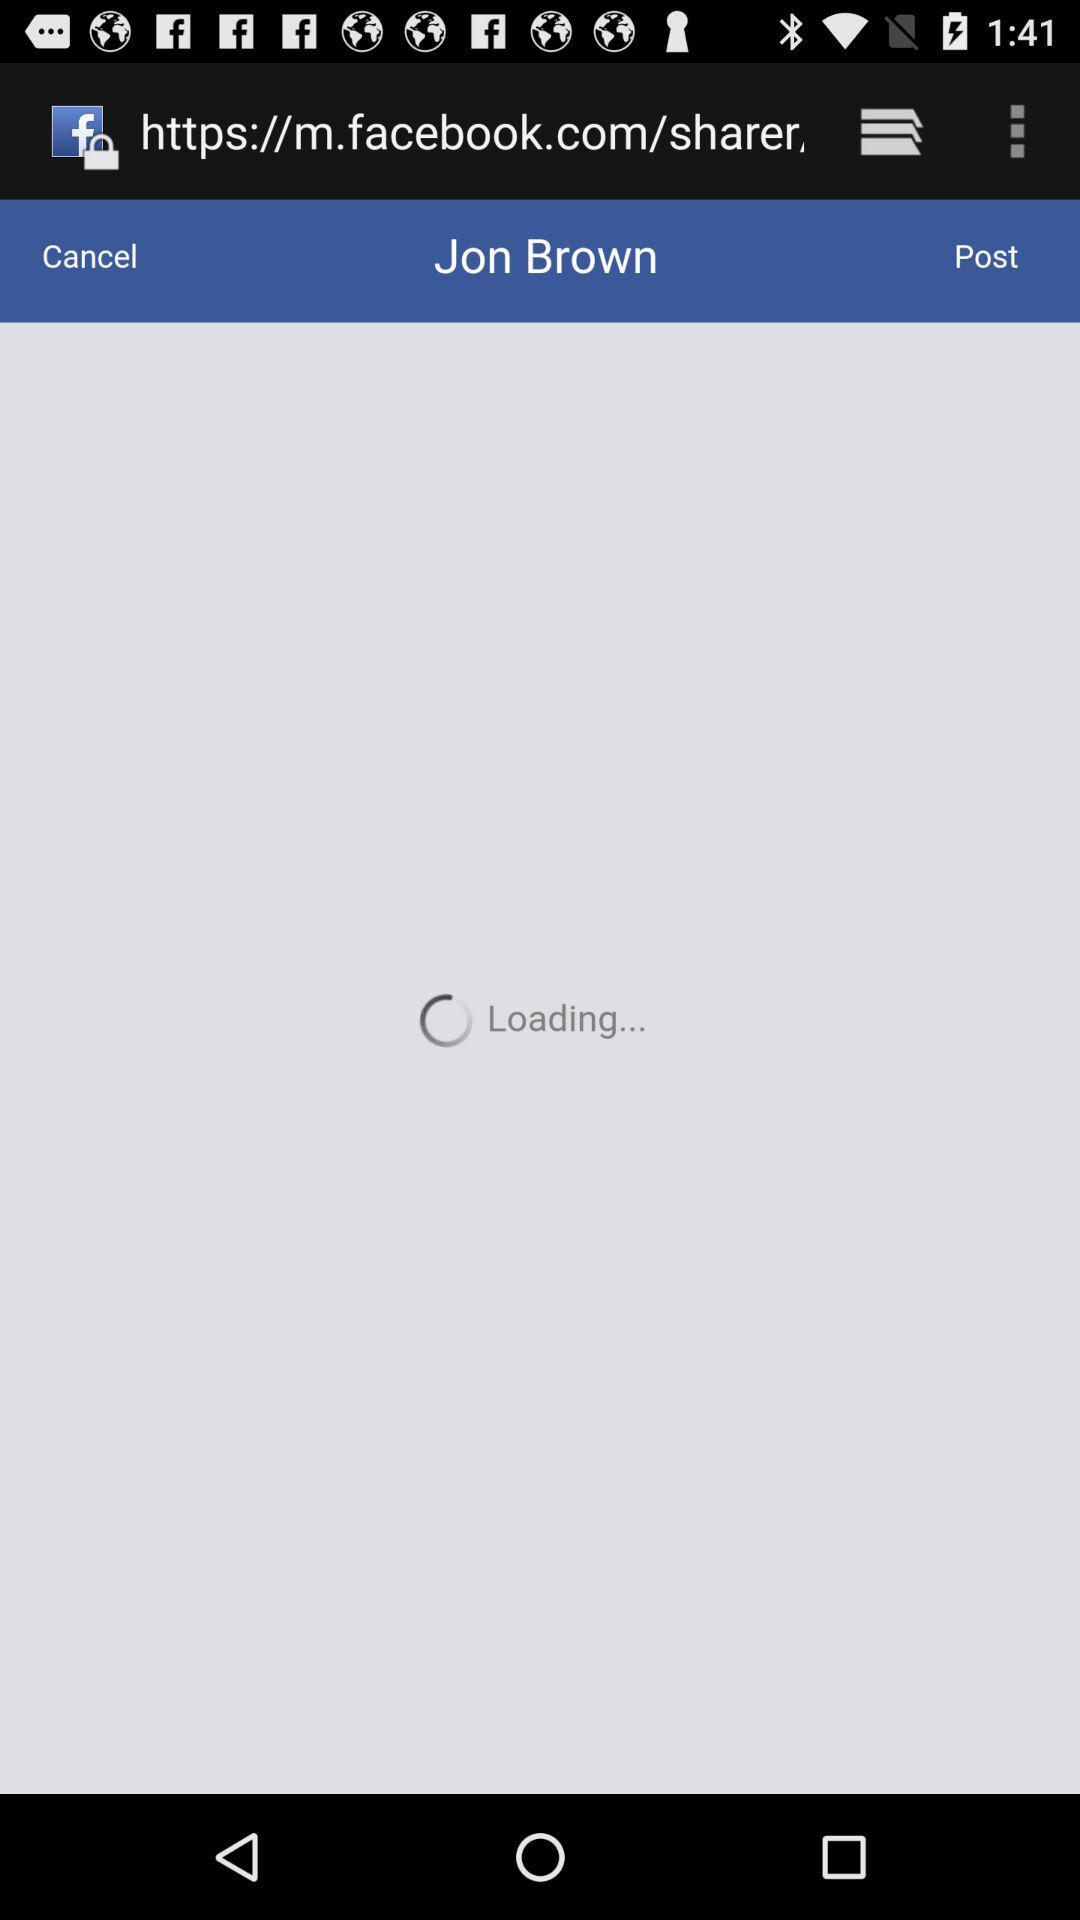What is the user name? The user name is Jon Brown. 